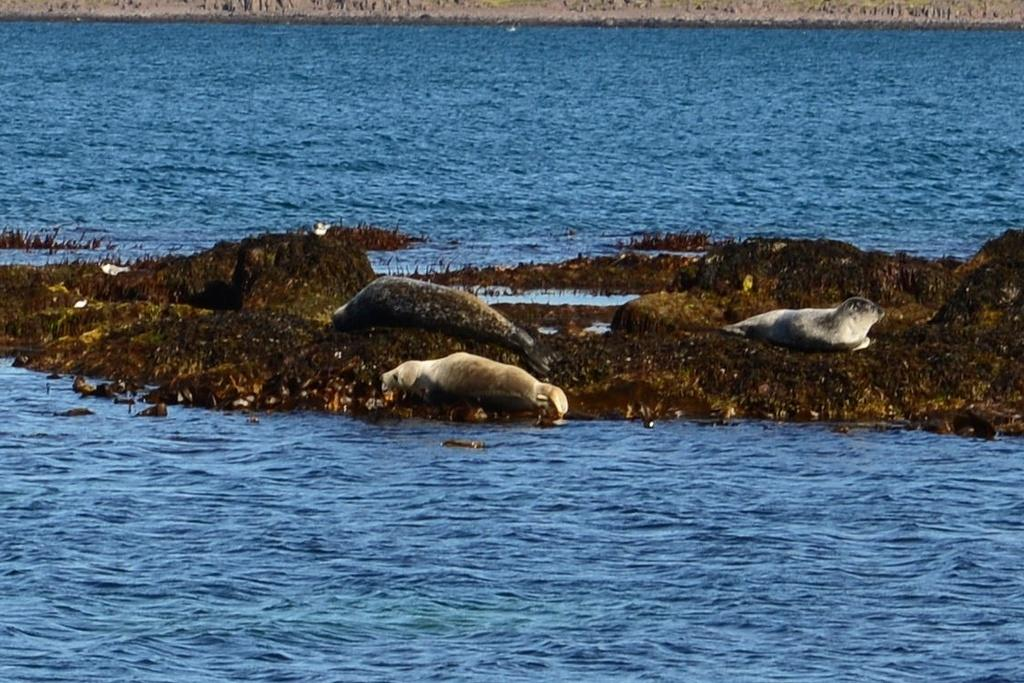What is the main subject of the image? There are animals on a rock in the image. What else can be seen in the image besides the animals? Plants are visible in the image. What is the large body of water in the image? There is a large water body in the image. What type of sofa can be seen in the image? There is no sofa present in the image. 